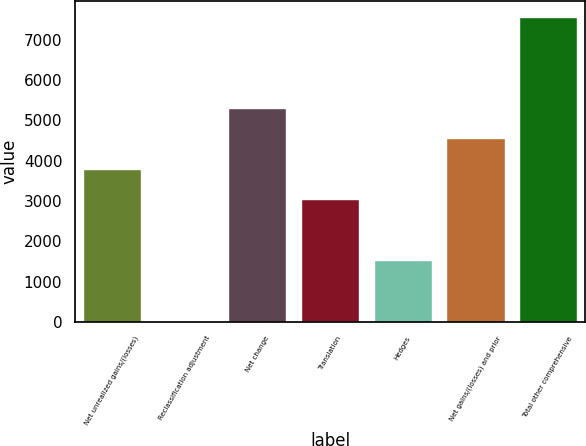<chart> <loc_0><loc_0><loc_500><loc_500><bar_chart><fcel>Net unrealized gains/(losses)<fcel>Reclassification adjustment<fcel>Net change<fcel>Translation<fcel>Hedges<fcel>Net gains/(losses) and prior<fcel>Total other comprehensive<nl><fcel>3795<fcel>14<fcel>5307.4<fcel>3038.8<fcel>1526.4<fcel>4551.2<fcel>7576<nl></chart> 